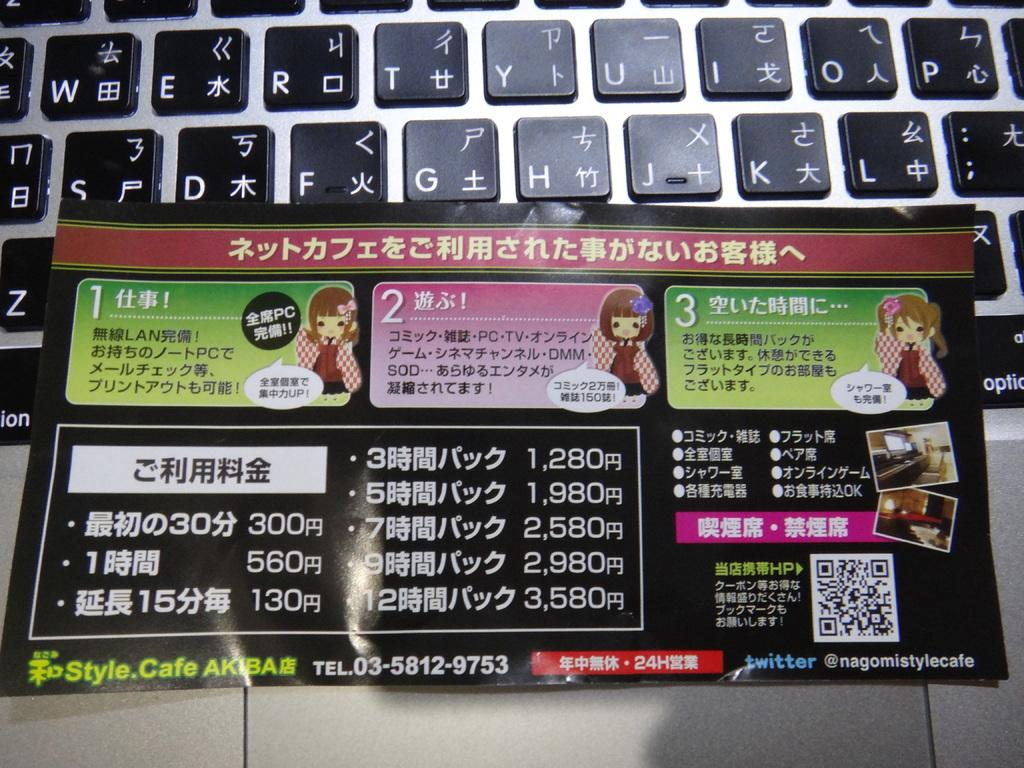<image>
Offer a succinct explanation of the picture presented. A leaflet on an open laptop has coloured sections numbered 1, 2 and 3. 